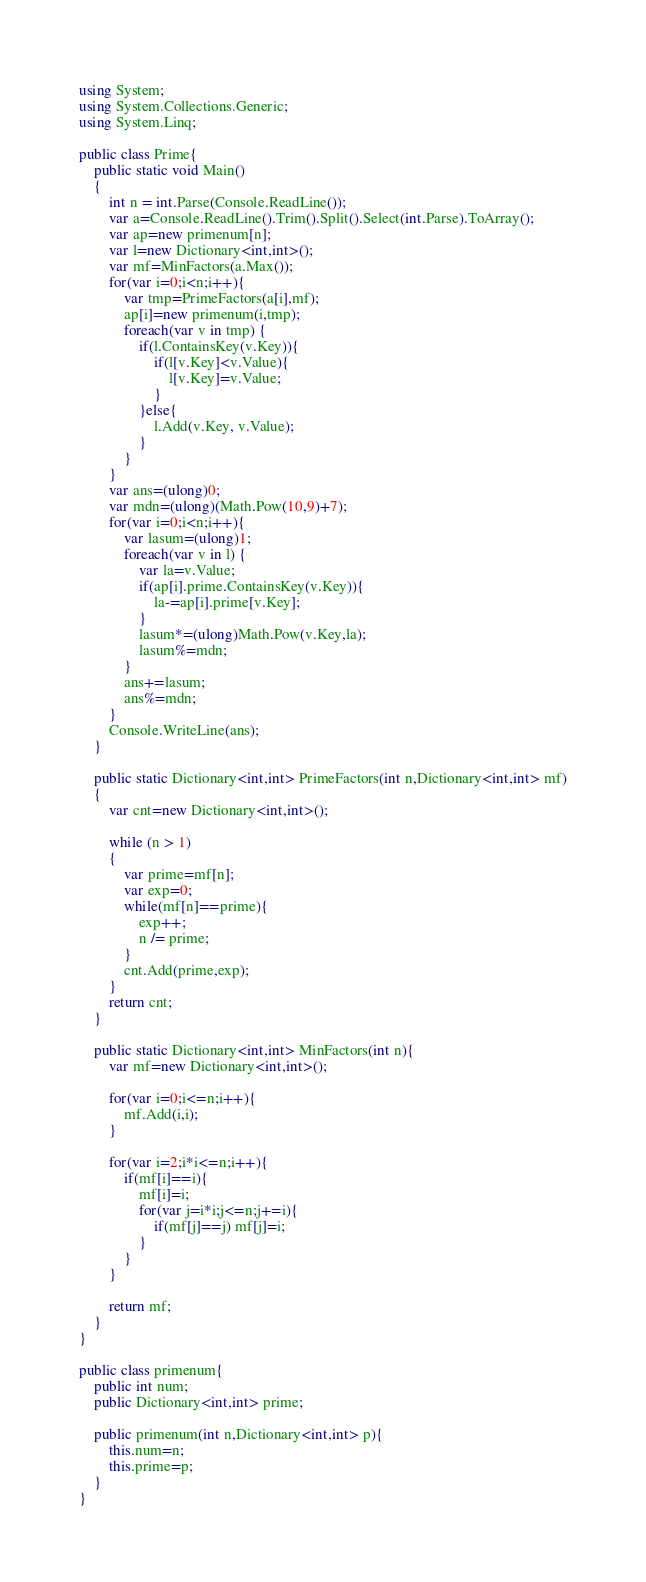Convert code to text. <code><loc_0><loc_0><loc_500><loc_500><_C#_>using System;
using System.Collections.Generic;
using System.Linq;

public class Prime{
    public static void Main()
    {
        int n = int.Parse(Console.ReadLine());
        var a=Console.ReadLine().Trim().Split().Select(int.Parse).ToArray();
        var ap=new primenum[n];
        var l=new Dictionary<int,int>();
        var mf=MinFactors(a.Max());
        for(var i=0;i<n;i++){
            var tmp=PrimeFactors(a[i],mf);
            ap[i]=new primenum(i,tmp);
            foreach(var v in tmp) {
                if(l.ContainsKey(v.Key)){
                    if(l[v.Key]<v.Value){
                        l[v.Key]=v.Value;
                    }
                }else{
                    l.Add(v.Key, v.Value);
                }
            }
        }
        var ans=(ulong)0;
        var mdn=(ulong)(Math.Pow(10,9)+7);
        for(var i=0;i<n;i++){
            var lasum=(ulong)1;
            foreach(var v in l) {
                var la=v.Value;
                if(ap[i].prime.ContainsKey(v.Key)){
                    la-=ap[i].prime[v.Key];
                }
                lasum*=(ulong)Math.Pow(v.Key,la);
                lasum%=mdn;
            }
            ans+=lasum;   
            ans%=mdn;
        }
        Console.WriteLine(ans);
    }

    public static Dictionary<int,int> PrimeFactors(int n,Dictionary<int,int> mf)
    {
        var cnt=new Dictionary<int,int>();

        while (n > 1)
        {
            var prime=mf[n];
            var exp=0;
            while(mf[n]==prime){
                exp++;
                n /= prime;
            }
            cnt.Add(prime,exp);
        }
        return cnt;
    }
    
    public static Dictionary<int,int> MinFactors(int n){
        var mf=new Dictionary<int,int>();
        
        for(var i=0;i<=n;i++){
            mf.Add(i,i);
        }
        
        for(var i=2;i*i<=n;i++){
            if(mf[i]==i){
                mf[i]=i;
                for(var j=i*i;j<=n;j+=i){
                    if(mf[j]==j) mf[j]=i;
                }
            }
        }
        
        return mf;
    }
}

public class primenum{
    public int num;
    public Dictionary<int,int> prime;
    
    public primenum(int n,Dictionary<int,int> p){
        this.num=n;
        this.prime=p;
    }
}
</code> 